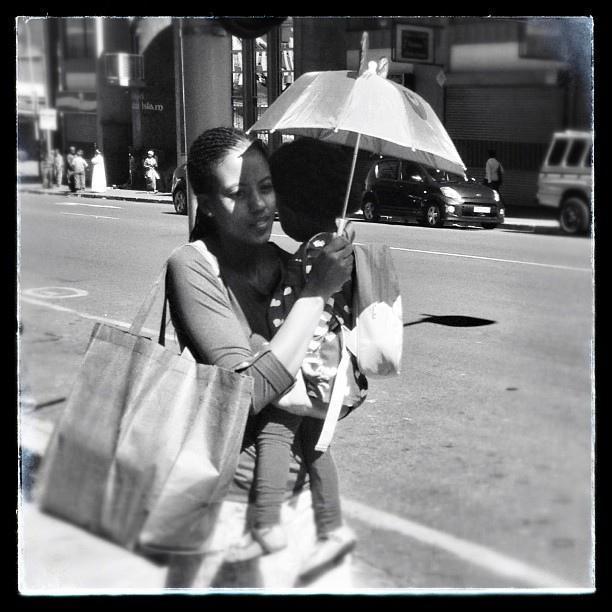How many people are there?
Give a very brief answer. 2. How many cars are visible?
Give a very brief answer. 2. How many feet of the elephant are on the ground?
Give a very brief answer. 0. 